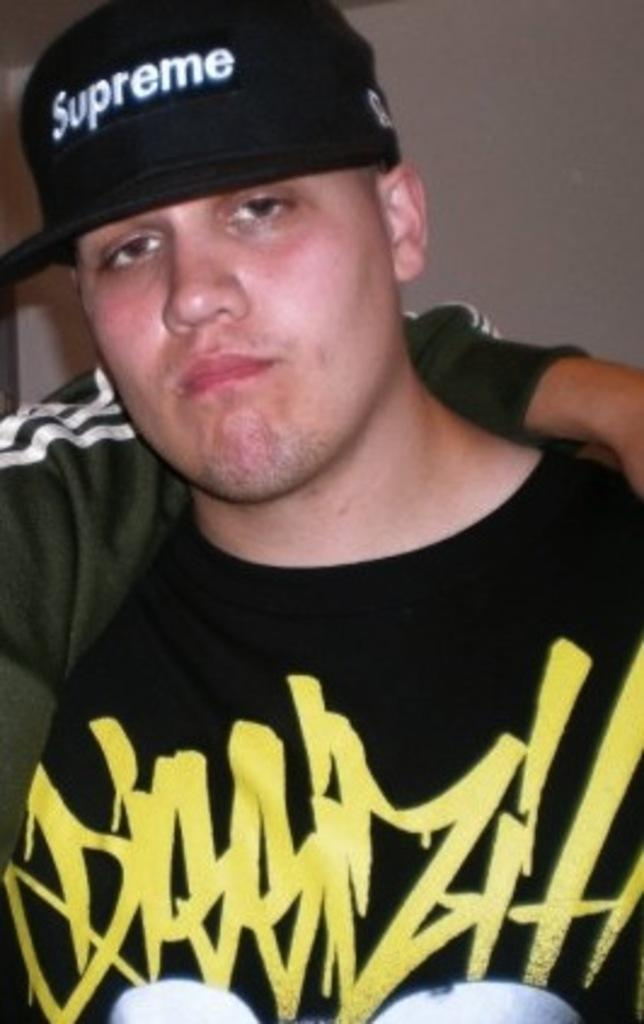<image>
Share a concise interpretation of the image provided. A guy wearing a yellow and black t shirt and a black hat that reads supreme. 